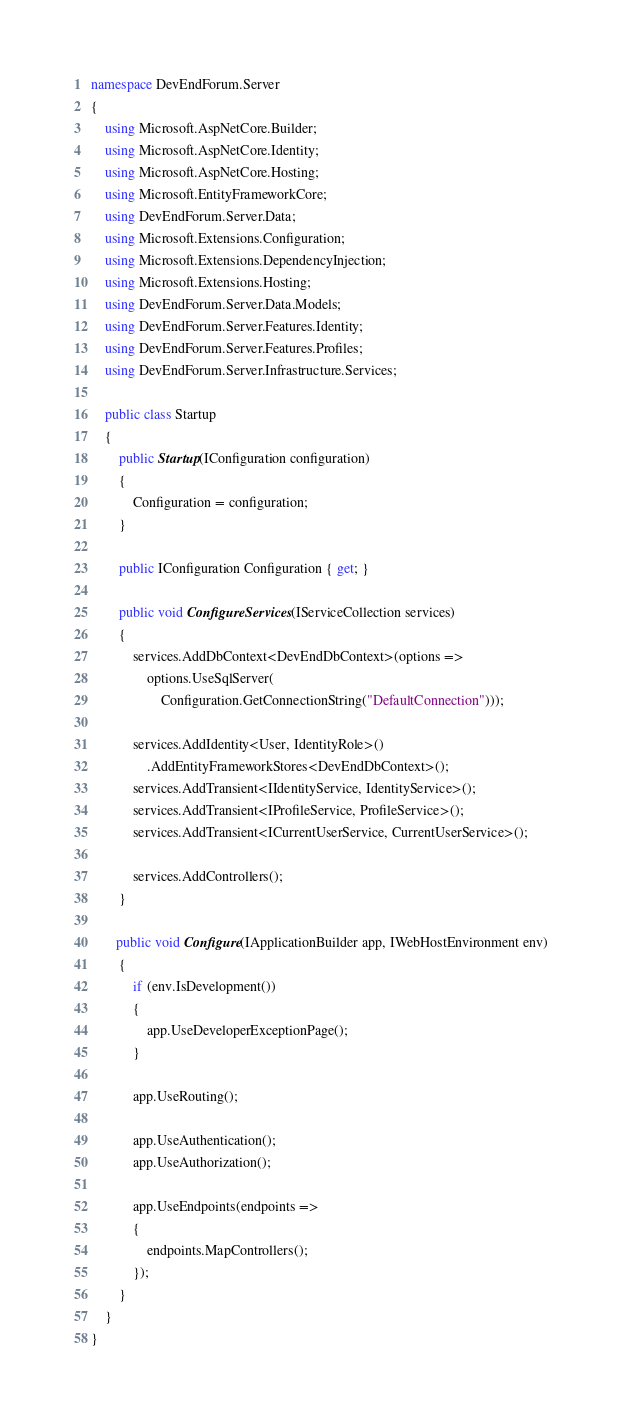<code> <loc_0><loc_0><loc_500><loc_500><_C#_>namespace DevEndForum.Server
{
    using Microsoft.AspNetCore.Builder;
    using Microsoft.AspNetCore.Identity;
    using Microsoft.AspNetCore.Hosting;
    using Microsoft.EntityFrameworkCore;
    using DevEndForum.Server.Data;
    using Microsoft.Extensions.Configuration;
    using Microsoft.Extensions.DependencyInjection;
    using Microsoft.Extensions.Hosting;
    using DevEndForum.Server.Data.Models;
    using DevEndForum.Server.Features.Identity;
    using DevEndForum.Server.Features.Profiles;
    using DevEndForum.Server.Infrastructure.Services;

    public class Startup
    {
        public Startup(IConfiguration configuration)
        {
            Configuration = configuration;
        }

        public IConfiguration Configuration { get; }

        public void ConfigureServices(IServiceCollection services)
        {
            services.AddDbContext<DevEndDbContext>(options =>
                options.UseSqlServer(
                    Configuration.GetConnectionString("DefaultConnection")));

            services.AddIdentity<User, IdentityRole>()
                .AddEntityFrameworkStores<DevEndDbContext>();
            services.AddTransient<IIdentityService, IdentityService>();
            services.AddTransient<IProfileService, ProfileService>();
            services.AddTransient<ICurrentUserService, CurrentUserService>();

            services.AddControllers();
        }

       public void Configure(IApplicationBuilder app, IWebHostEnvironment env)
        {
            if (env.IsDevelopment())
            {
                app.UseDeveloperExceptionPage();
            }

            app.UseRouting();

            app.UseAuthentication();
            app.UseAuthorization();

            app.UseEndpoints(endpoints =>
            {
                endpoints.MapControllers();
            });
        }
    }
}
</code> 